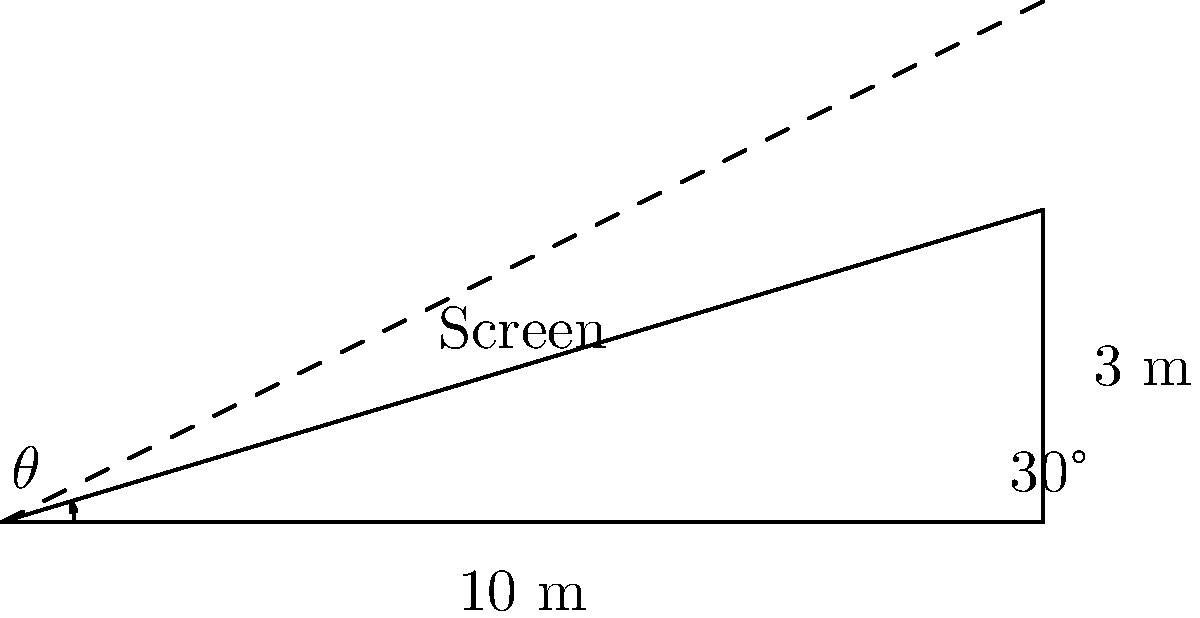You need to project lyrics onto a slanted screen in the worship hall. The screen is 10 meters wide and raised 3 meters on one end. If the projector is placed at ground level, what is the angle of elevation ($\theta$) required to project the lyrics onto the center of the screen? To find the angle of elevation ($\theta$), we need to use trigonometry. Let's approach this step-by-step:

1. Identify the right triangle:
   - The base of the triangle is the width of the screen: 10 meters
   - The height is half the raised height: 3/2 = 1.5 meters (since we're aiming for the center)

2. Use the tangent function to find the angle:
   $\tan(\theta) = \frac{\text{opposite}}{\text{adjacent}} = \frac{\text{height}}{\text{width}}$

3. Substitute the values:
   $\tan(\theta) = \frac{1.5}{10}$

4. Calculate the inverse tangent (arctan) to find $\theta$:
   $\theta = \arctan(\frac{1.5}{10})$

5. Evaluate:
   $\theta \approx 8.53°$

Therefore, the projector needs to be angled at approximately 8.53 degrees from the horizontal to hit the center of the screen.
Answer: $8.53°$ 